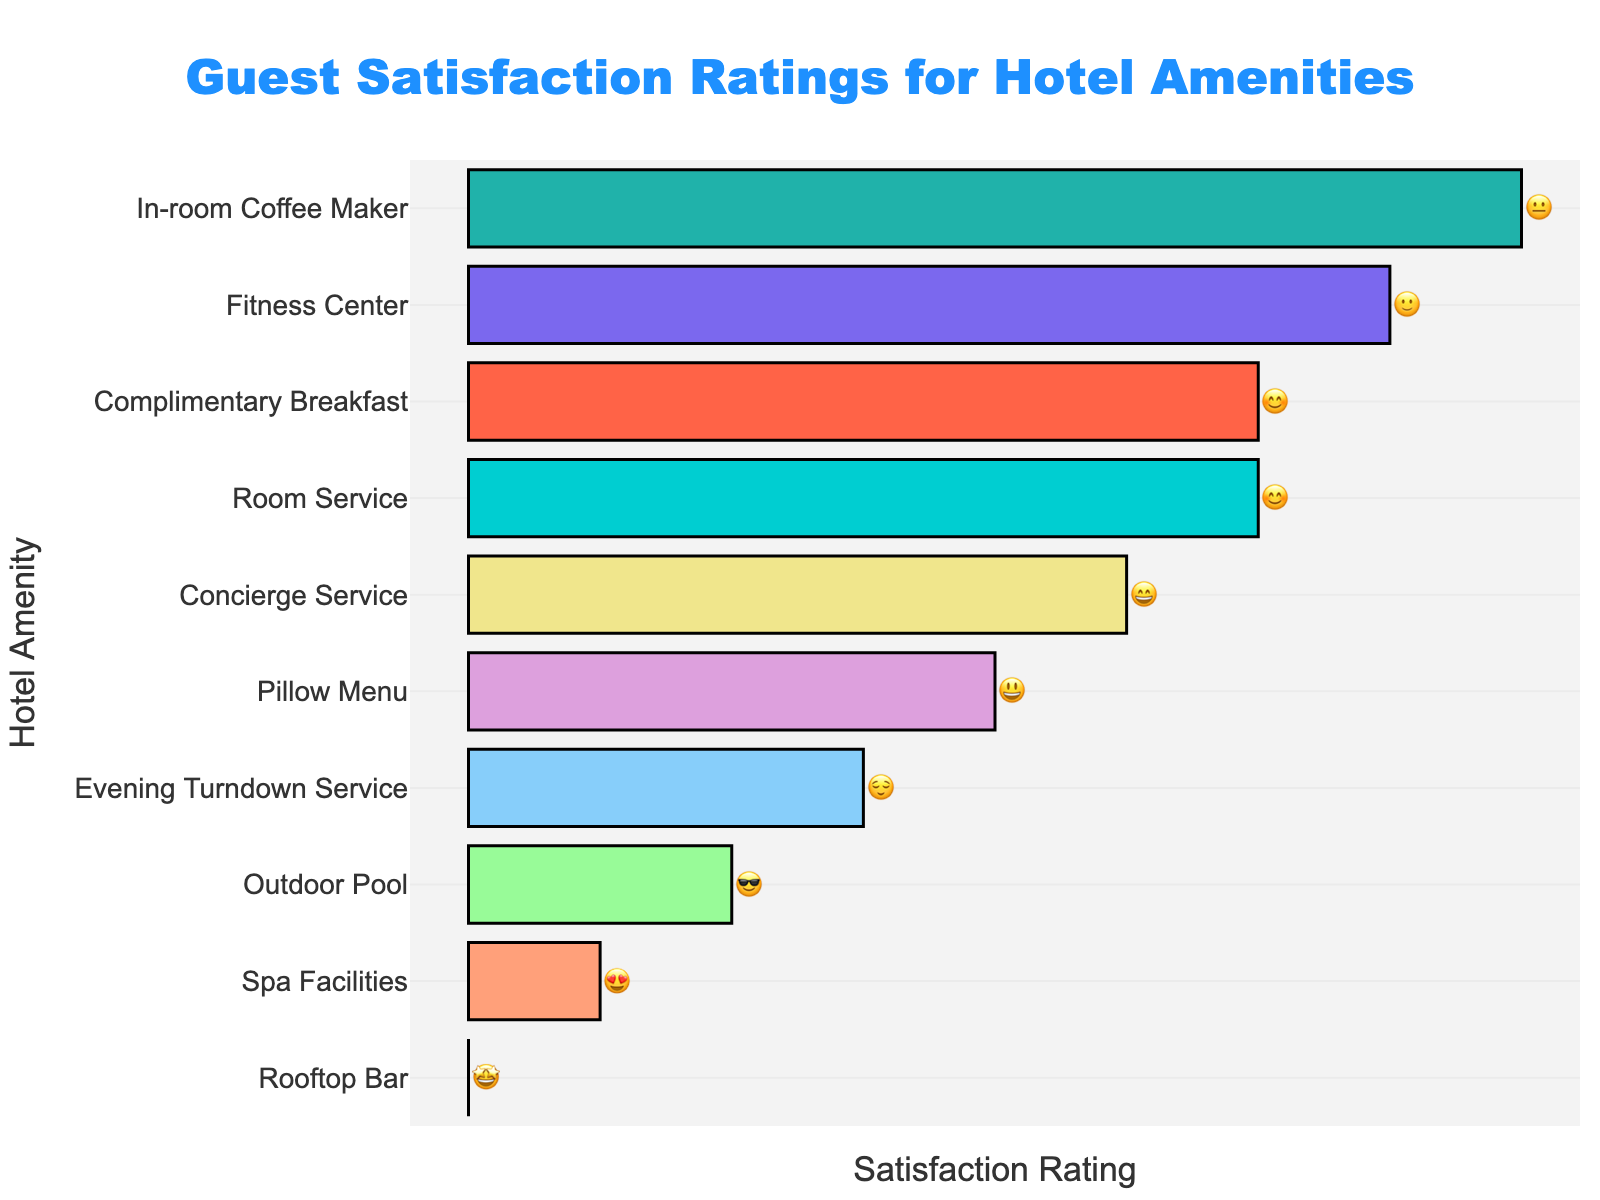How many amenities have a 😊 rating? Look at the number of bars associated with the 😊 emoji. There are two amenities with a 😊 rating: Room Service and Complimentary Breakfast.
Answer: 2 Which amenity has the highest satisfaction rating? Find the bar with the most positive emoji, which is 🤩 for Rooftop Bar.
Answer: Rooftop Bar What is the satisfaction rating for the Fitness Center? Check the emoji associated with the Fitness Center, which is 🙂.
Answer: 🙂 Which amenities have a 😄 rating? Identify the amenities with the 😄 emoji, which is Concierge Service.
Answer: Concierge Service Which amenity has the lowest satisfaction rating? Locate the bar with the least positive emoji, which is 😐 for In-room Coffee Maker.
Answer: In-room Coffee Maker How does the rating for Evening Turndown Service compare to the rating for the Outdoor Pool? Compare the emojis for both amenities. Evening Turndown Service has 😌, and Outdoor Pool has 😎. 😎 is slightly more positive than 😌.
Answer: Outdoor Pool has a higher rating What is the average satisfaction rating for the amenities? To find the average, map the emojis to a scale: 😐 = 1, 🙂 = 2, 😊 = 3, 😄 = 4, 😃 = 5, 😌 = 6, 😎 = 7, 😍 = 8, 🤩 = 9. Then sum these values and divide by the number of amenities (10). (1+2+3+4+5+6+7+8+9+3)/10 = 4.8
Answer: 4.8 Which amenities have a rating of 5 or higher on the ordinal scale? Convert the emojis to their ordinal values and select those with a value of 5 or more: 😃, 😌, 😎, 😍, 🤩 correspond to Pillow Menu, Evening Turndown Service, Outdoor Pool, Spa Facilities, and Rooftop Bar.
Answer: Pillow Menu, Evening Turndown Service, Outdoor Pool, Spa Facilities, Rooftop Bar 